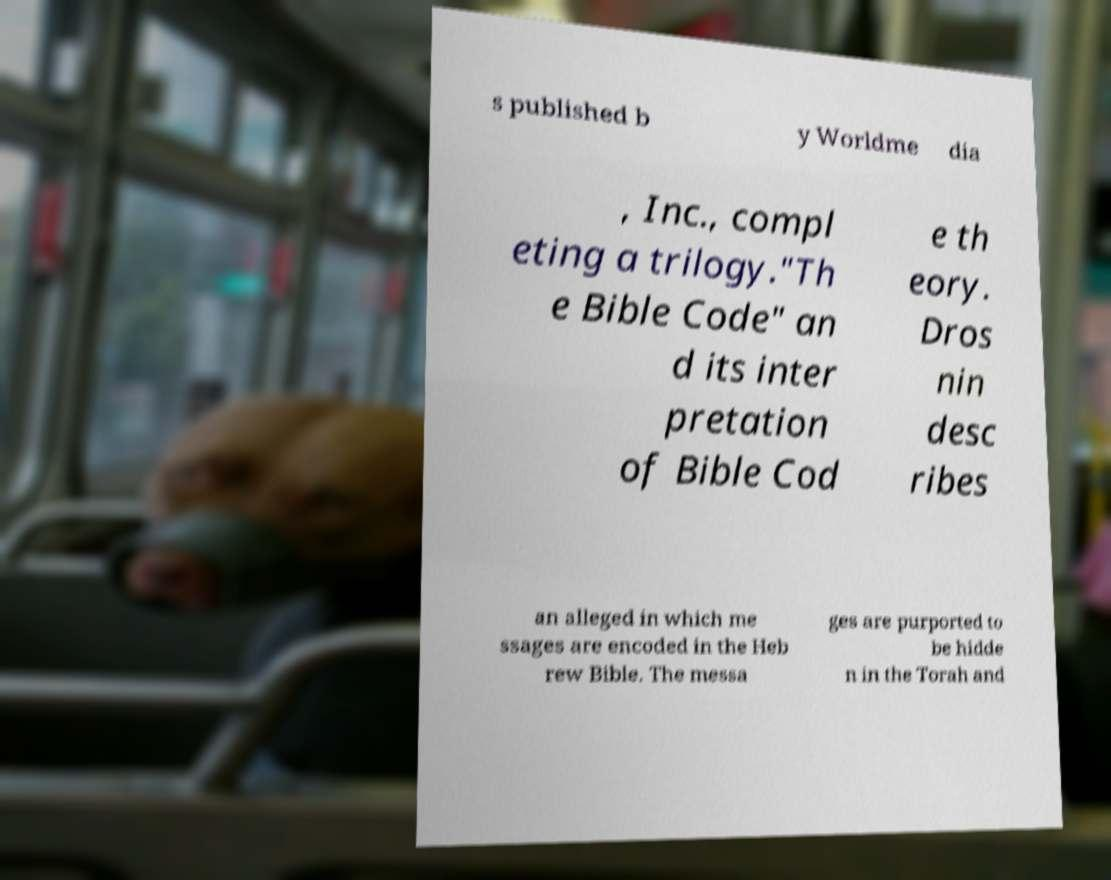Can you read and provide the text displayed in the image?This photo seems to have some interesting text. Can you extract and type it out for me? s published b y Worldme dia , Inc., compl eting a trilogy."Th e Bible Code" an d its inter pretation of Bible Cod e th eory. Dros nin desc ribes an alleged in which me ssages are encoded in the Heb rew Bible. The messa ges are purported to be hidde n in the Torah and 